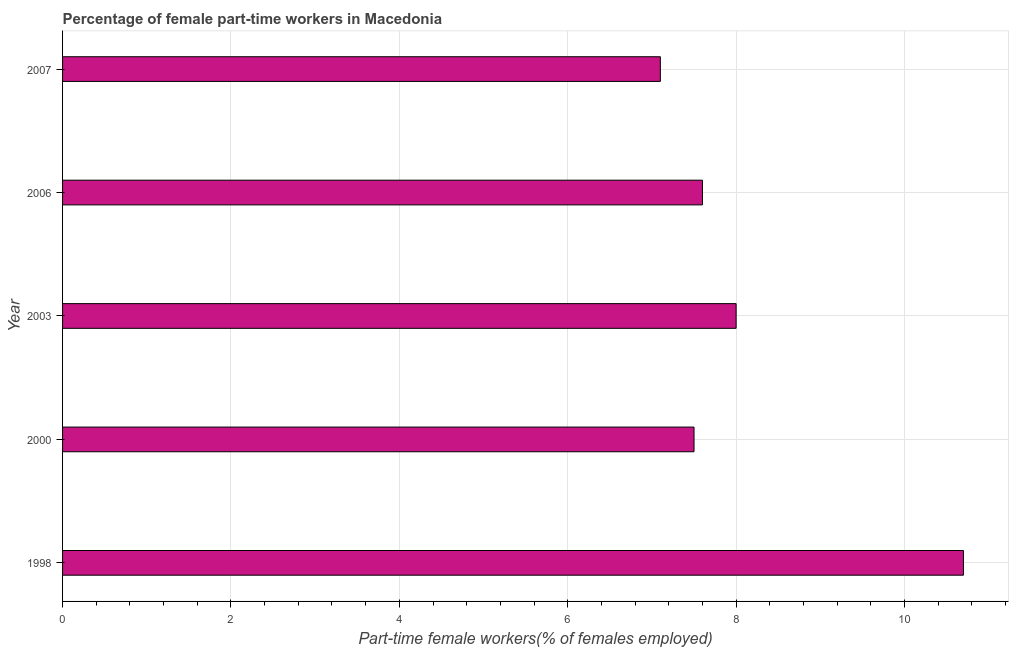Does the graph contain grids?
Provide a succinct answer. Yes. What is the title of the graph?
Offer a terse response. Percentage of female part-time workers in Macedonia. What is the label or title of the X-axis?
Offer a terse response. Part-time female workers(% of females employed). What is the label or title of the Y-axis?
Your answer should be very brief. Year. What is the percentage of part-time female workers in 2007?
Keep it short and to the point. 7.1. Across all years, what is the maximum percentage of part-time female workers?
Make the answer very short. 10.7. Across all years, what is the minimum percentage of part-time female workers?
Make the answer very short. 7.1. In which year was the percentage of part-time female workers maximum?
Give a very brief answer. 1998. What is the sum of the percentage of part-time female workers?
Give a very brief answer. 40.9. What is the average percentage of part-time female workers per year?
Ensure brevity in your answer.  8.18. What is the median percentage of part-time female workers?
Give a very brief answer. 7.6. Do a majority of the years between 2000 and 2007 (inclusive) have percentage of part-time female workers greater than 2.8 %?
Your response must be concise. Yes. What is the ratio of the percentage of part-time female workers in 2006 to that in 2007?
Provide a short and direct response. 1.07. What is the difference between the highest and the second highest percentage of part-time female workers?
Keep it short and to the point. 2.7. Is the sum of the percentage of part-time female workers in 2006 and 2007 greater than the maximum percentage of part-time female workers across all years?
Make the answer very short. Yes. What is the difference between the highest and the lowest percentage of part-time female workers?
Offer a terse response. 3.6. In how many years, is the percentage of part-time female workers greater than the average percentage of part-time female workers taken over all years?
Offer a very short reply. 1. What is the difference between two consecutive major ticks on the X-axis?
Give a very brief answer. 2. What is the Part-time female workers(% of females employed) in 1998?
Provide a succinct answer. 10.7. What is the Part-time female workers(% of females employed) of 2000?
Make the answer very short. 7.5. What is the Part-time female workers(% of females employed) in 2006?
Ensure brevity in your answer.  7.6. What is the Part-time female workers(% of females employed) in 2007?
Provide a succinct answer. 7.1. What is the difference between the Part-time female workers(% of females employed) in 1998 and 2006?
Your response must be concise. 3.1. What is the difference between the Part-time female workers(% of females employed) in 1998 and 2007?
Provide a succinct answer. 3.6. What is the difference between the Part-time female workers(% of females employed) in 2006 and 2007?
Make the answer very short. 0.5. What is the ratio of the Part-time female workers(% of females employed) in 1998 to that in 2000?
Your response must be concise. 1.43. What is the ratio of the Part-time female workers(% of females employed) in 1998 to that in 2003?
Offer a terse response. 1.34. What is the ratio of the Part-time female workers(% of females employed) in 1998 to that in 2006?
Provide a succinct answer. 1.41. What is the ratio of the Part-time female workers(% of females employed) in 1998 to that in 2007?
Your answer should be compact. 1.51. What is the ratio of the Part-time female workers(% of females employed) in 2000 to that in 2003?
Offer a very short reply. 0.94. What is the ratio of the Part-time female workers(% of females employed) in 2000 to that in 2007?
Make the answer very short. 1.06. What is the ratio of the Part-time female workers(% of females employed) in 2003 to that in 2006?
Offer a very short reply. 1.05. What is the ratio of the Part-time female workers(% of females employed) in 2003 to that in 2007?
Offer a very short reply. 1.13. What is the ratio of the Part-time female workers(% of females employed) in 2006 to that in 2007?
Provide a succinct answer. 1.07. 